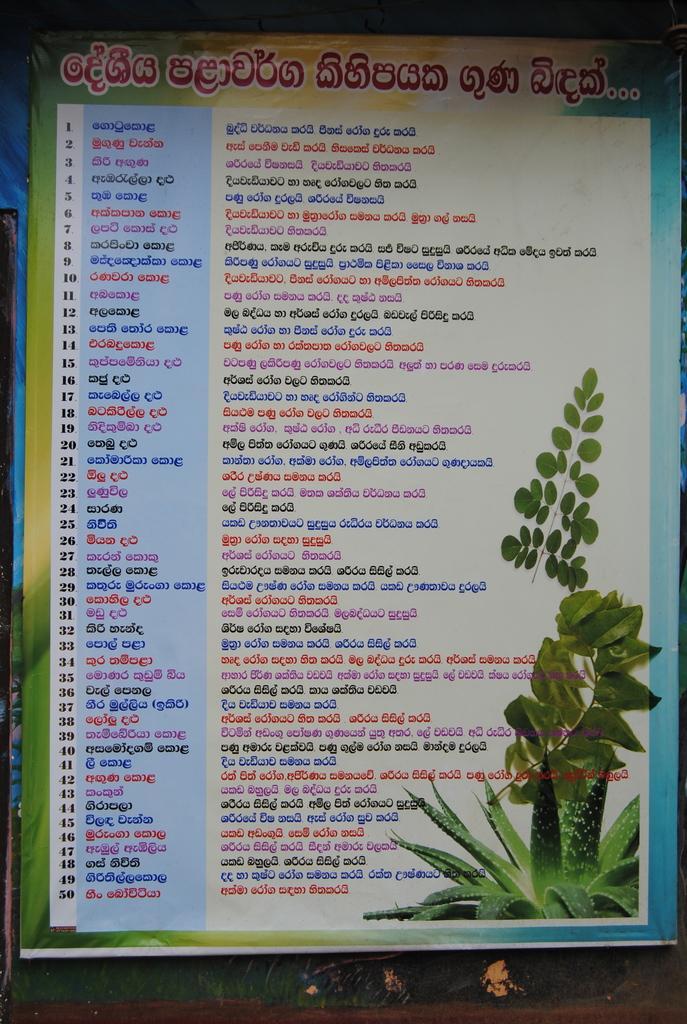Please provide a concise description of this image. In this image we can see the banner with the text, leaves and also the plant image. 